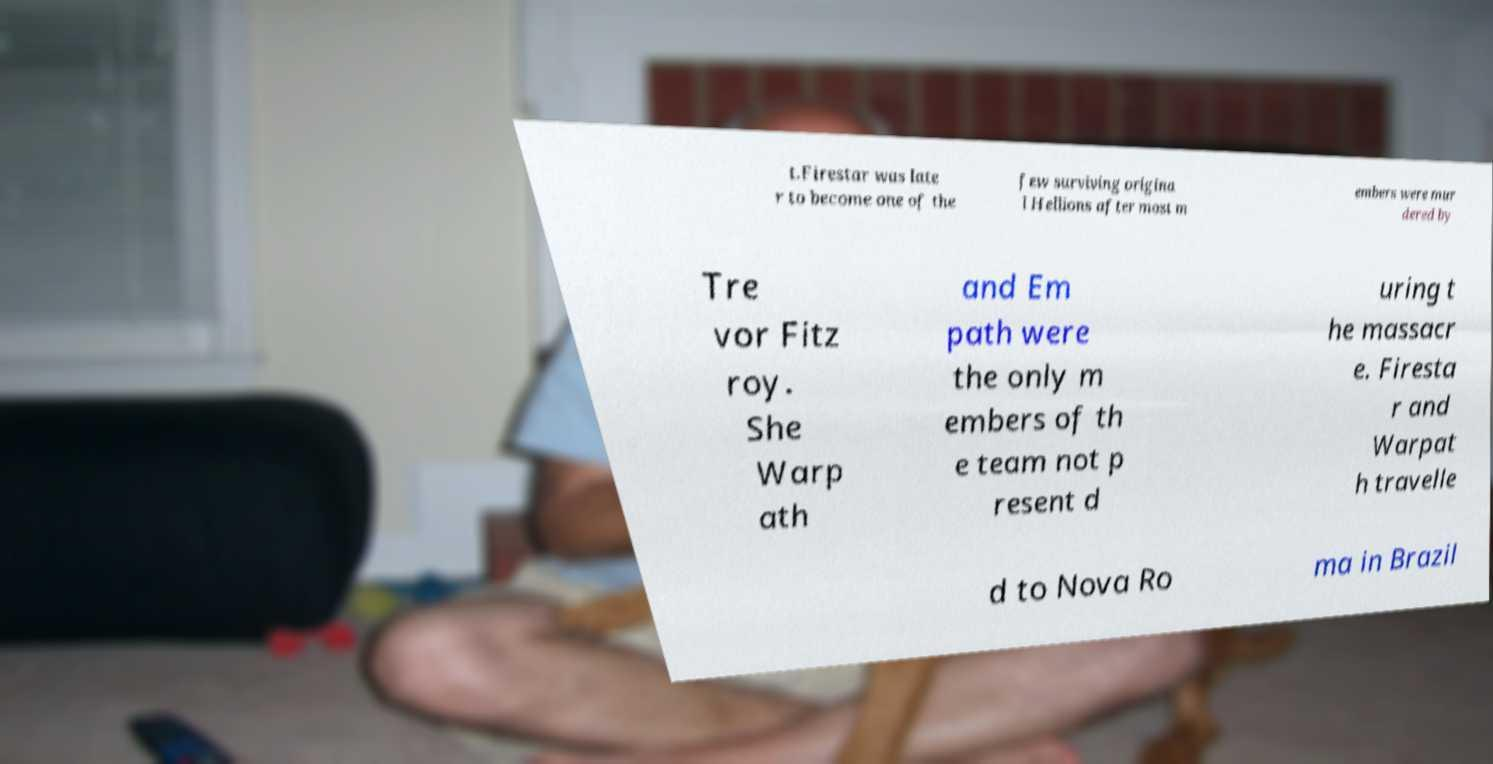Please read and relay the text visible in this image. What does it say? t.Firestar was late r to become one of the few surviving origina l Hellions after most m embers were mur dered by Tre vor Fitz roy. She Warp ath and Em path were the only m embers of th e team not p resent d uring t he massacr e. Firesta r and Warpat h travelle d to Nova Ro ma in Brazil 